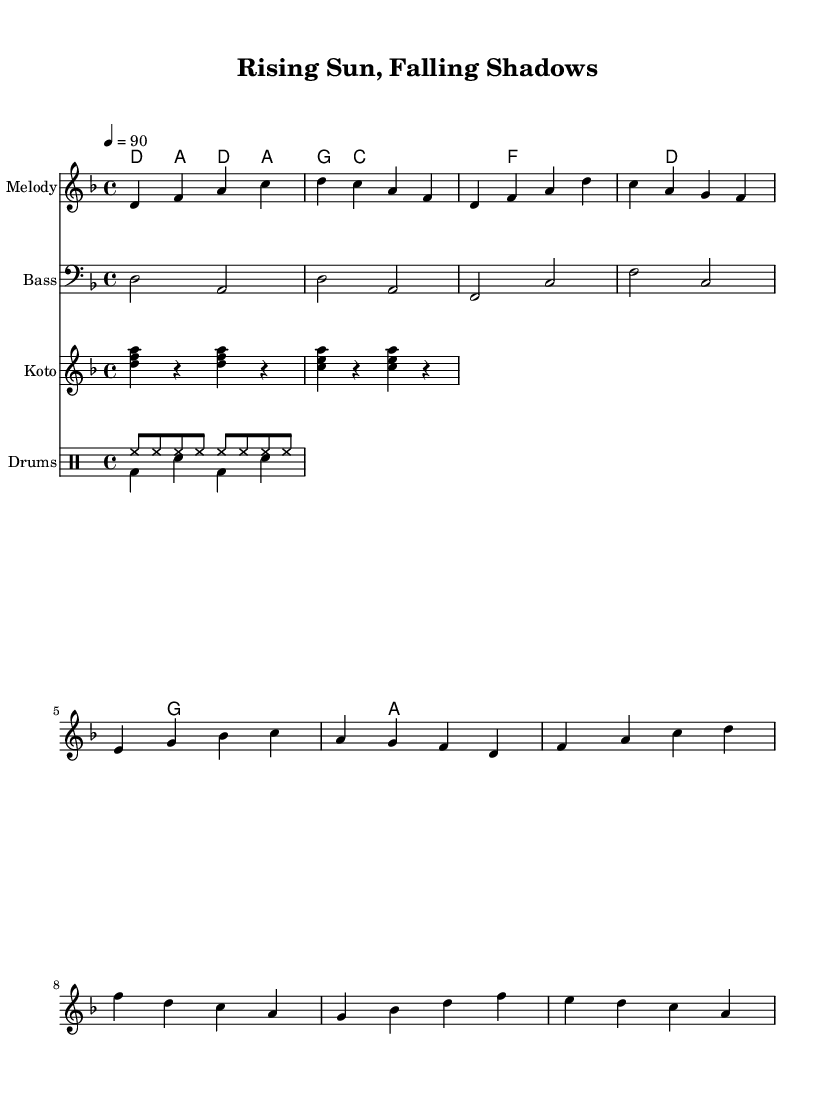what is the key signature of this music? The key signature is D minor, which includes one flat (B flat). This information can be determined from the beginning of the sheet music where the key signature is indicated.
Answer: D minor what is the time signature of this music? The time signature is 4/4, as noted at the beginning of the score. This means there are four beats in each measure, and the quarter note gets one beat.
Answer: 4/4 what is the tempo marking of this piece? The tempo marking is 90 beats per minute, indicated at the beginning with the tempo indication, suggesting a moderate pace for the music.
Answer: 90 how many measures are there in the chorus section? The chorus section has a total of four measures, which can be counted in the score where the melody and harmonies are laid out for the chorus.
Answer: 4 which instrument plays the arpeggiated chords? The instrument playing the arpeggiated chords is the koto, as indicated in the music staff where the koto part is notated.
Answer: Koto which instruments are featured in this piece? The instruments featured include Melody, Bass, Koto, and Drums, as seen in the different staves for each instrument listed in the score.
Answer: Melody, Bass, Koto, Drums what type of song structure does this piece represent in Hip Hop? The song structure represents a common verse-chorus format, typical in Hip Hop, where verses are followed by the chorus, which can be identified in the layout of melody and harmony sections.
Answer: Verse-Chorus 